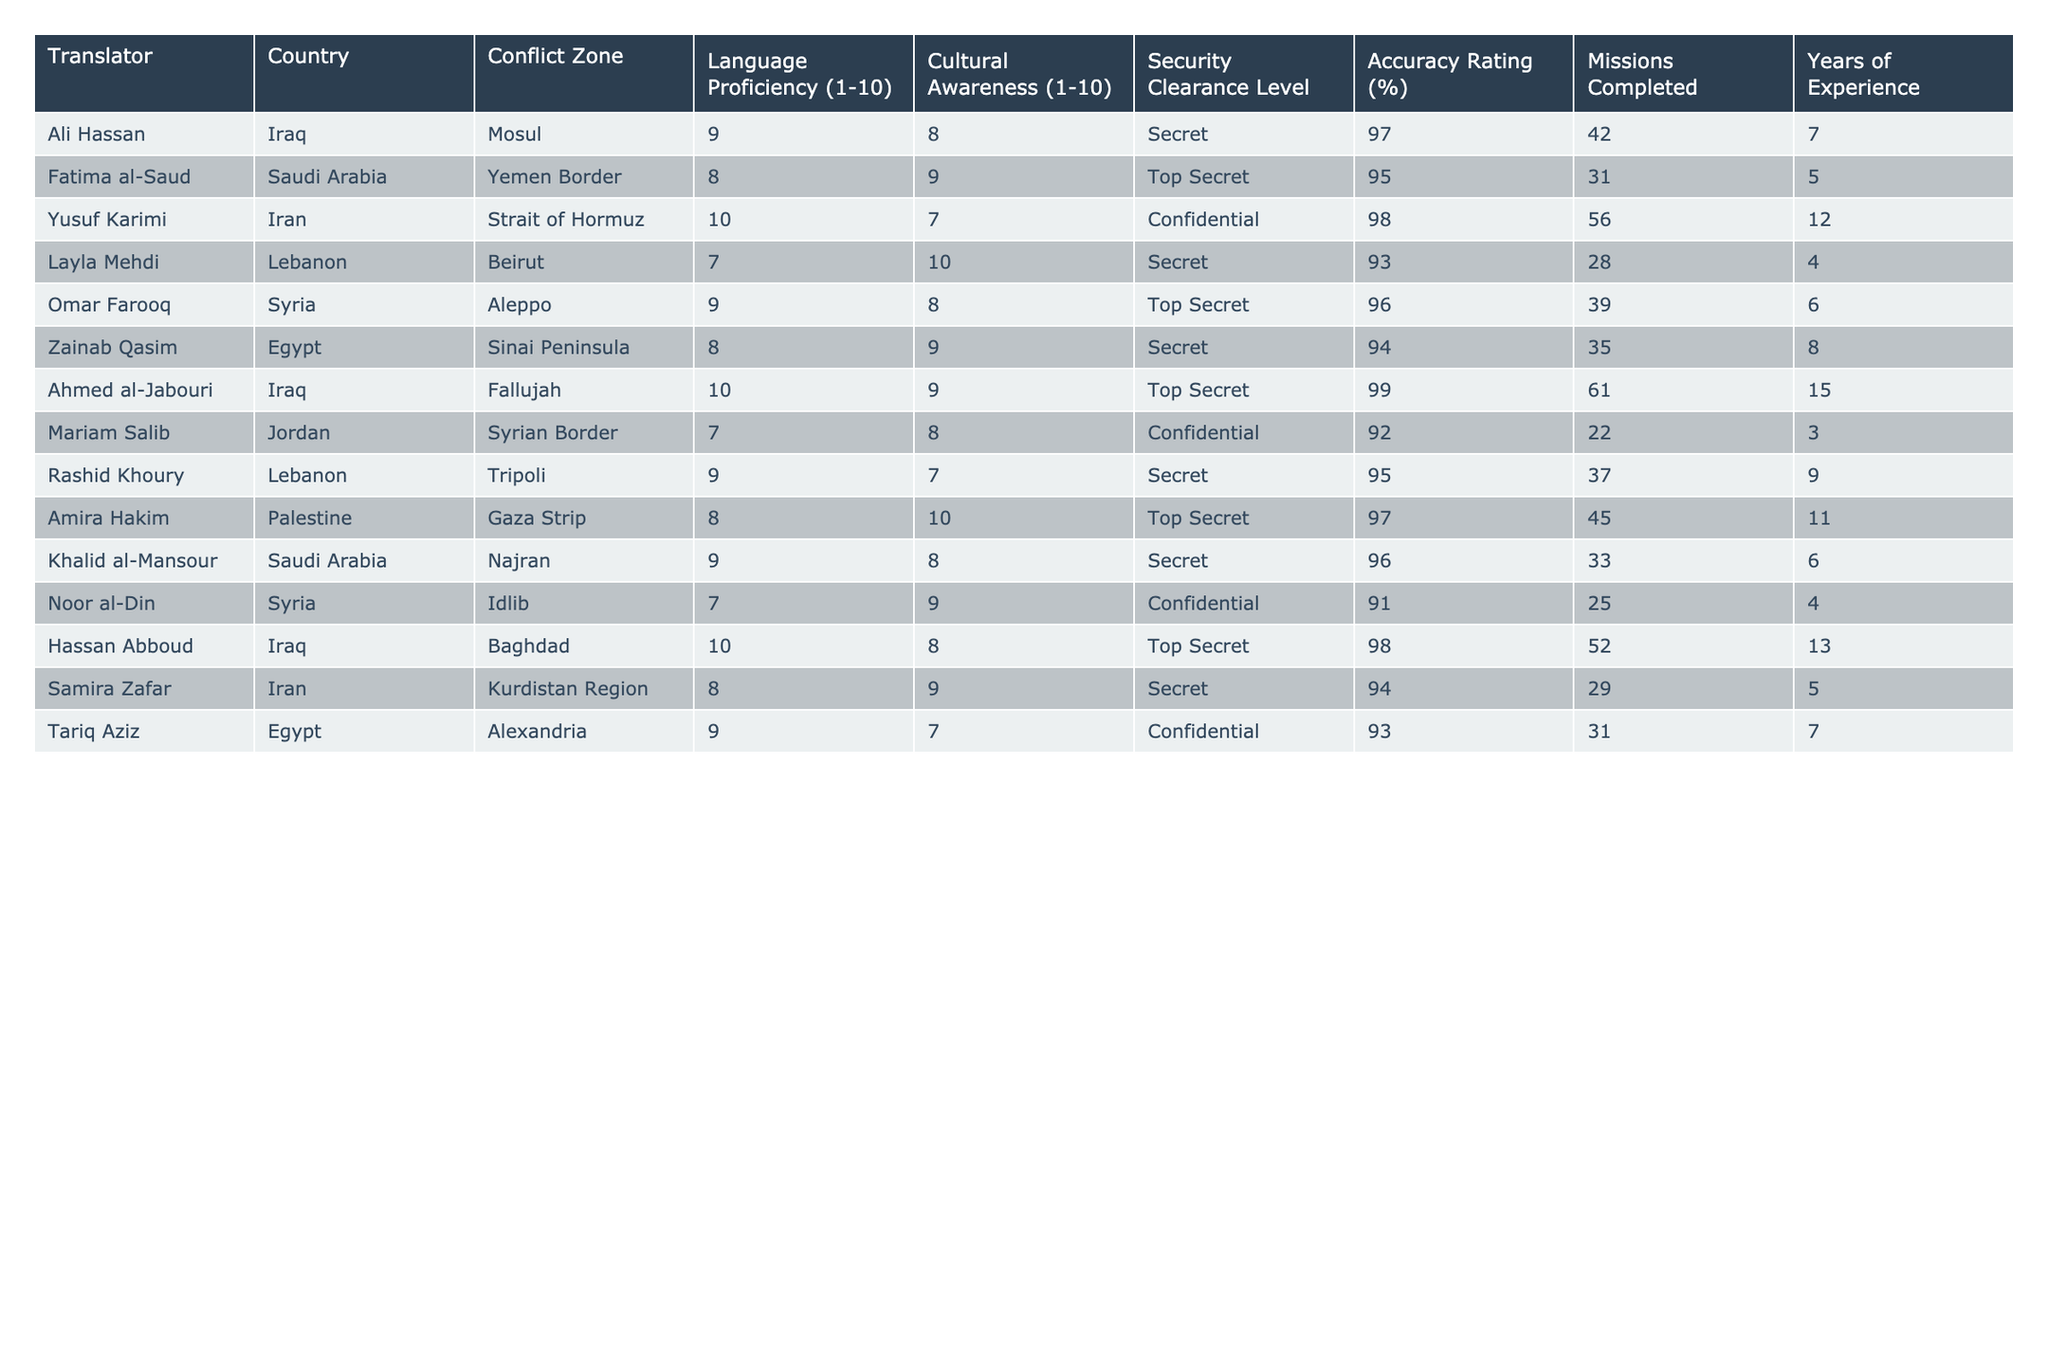What is the accuracy rating of Ali Hassan? The accuracy rating is explicitly listed in the table under the Accuracy Rating column for Ali Hassan, which is 97%.
Answer: 97% Which translator has the highest years of experience? By examining the Years of Experience column, Ahmed al-Jabouri has the highest at 15 years.
Answer: 15 Is there a translator with a security clearance level of Top Secret that has completed more than 50 missions? By checking both the Security Clearance Level and Missions Completed columns, Ahmed al-Jabouri is the only one with Top Secret level who completed 61 missions, meeting the criteria.
Answer: Yes What is the average language proficiency rating of translators working in Iraq? The Language Proficiency ratings of translators in Iraq are 9 (Ali Hassan), 10 (Ahmed al-Jabouri), and 10 (Hassan Abboud), totaling 29. Dividing this by 3, the average is 9.67.
Answer: 9.67 How many translators have a cultural awareness rating of 10? In the Cultural Awareness column, Layla Mehdi and Amira Hakim both have a rating of 10, making it a total of 2 translators.
Answer: 2 Which conflict zone has the most translators listed? Counting the conflict zones in the table, Iraq has 3 translators (Mosul, Fallujah, Baghdad), which is the highest compared to others.
Answer: Iraq What is the accuracy rating difference between the translator with the highest and the lowest accuracy ratings? The highest accuracy rating is 99% (Ahmed al-Jabouri) and the lowest is 91% (Noor al-Din). The difference is 99 - 91 = 8%.
Answer: 8% What percentage of translators are rated with a language proficiency of 9 or higher? There are 10 translators, and 6 have a language proficiency of 9 or higher (Ali Hassan, Yusuf Karimi, Ahmed al-Jabouri, Omar Farooq, Khalid al-Mansour, Tariq Aziz). Thus, (6/10) * 100 = 60%.
Answer: 60% Which translator has the lowest accuracy rating, and what is that rating? Checking the Accuracy Rating column, Noor al-Din has the lowest rating of 91%.
Answer: Noor al-Din, 91% Are there any translators in the table who are proficient in Arabic and hold a Top Secret security clearance? By inspecting the Language proficiency and Security Clearance columns, Fatima al-Saud, Omar Farooq, Ahmed al-Jabouri, and Amira Hakim meet these criteria.
Answer: Yes, 4 translators 